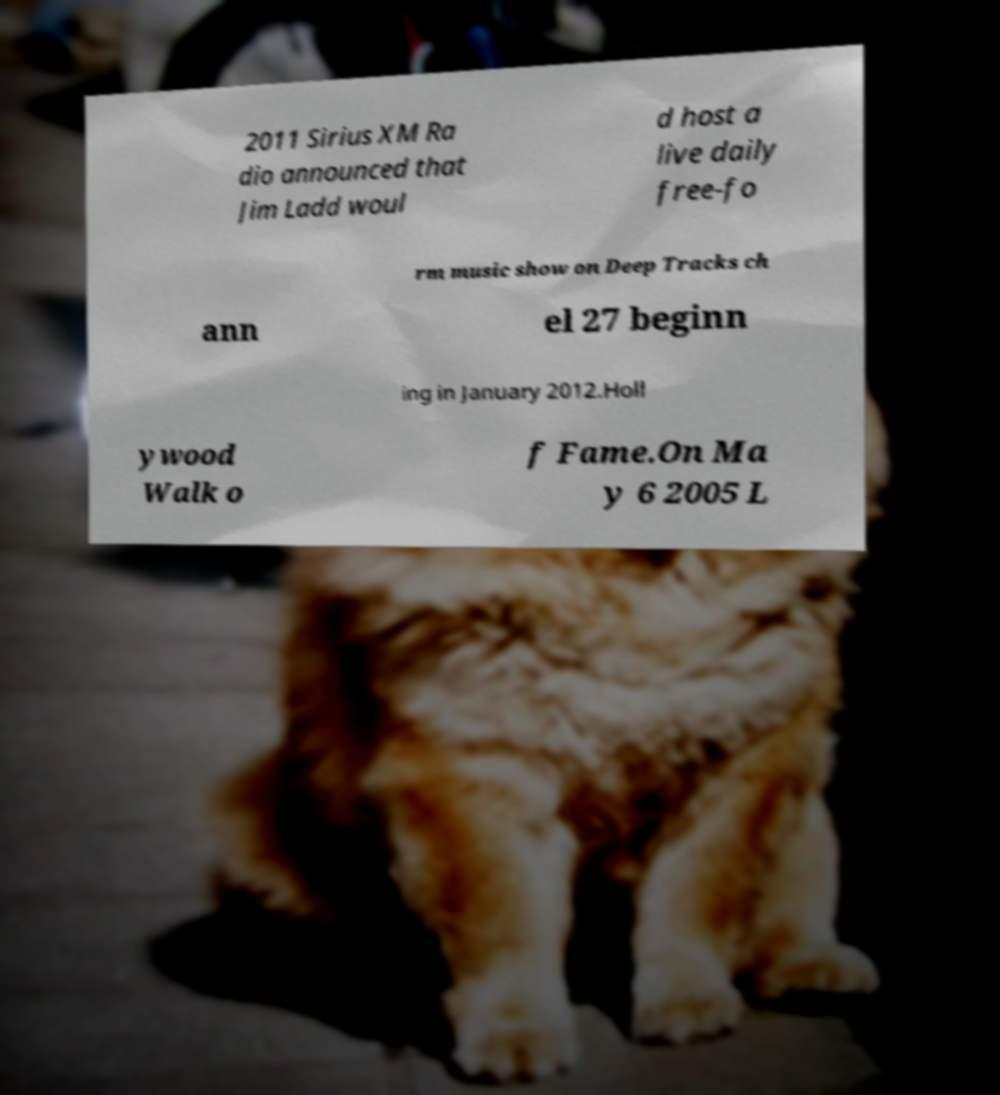Can you accurately transcribe the text from the provided image for me? 2011 Sirius XM Ra dio announced that Jim Ladd woul d host a live daily free-fo rm music show on Deep Tracks ch ann el 27 beginn ing in January 2012.Holl ywood Walk o f Fame.On Ma y 6 2005 L 